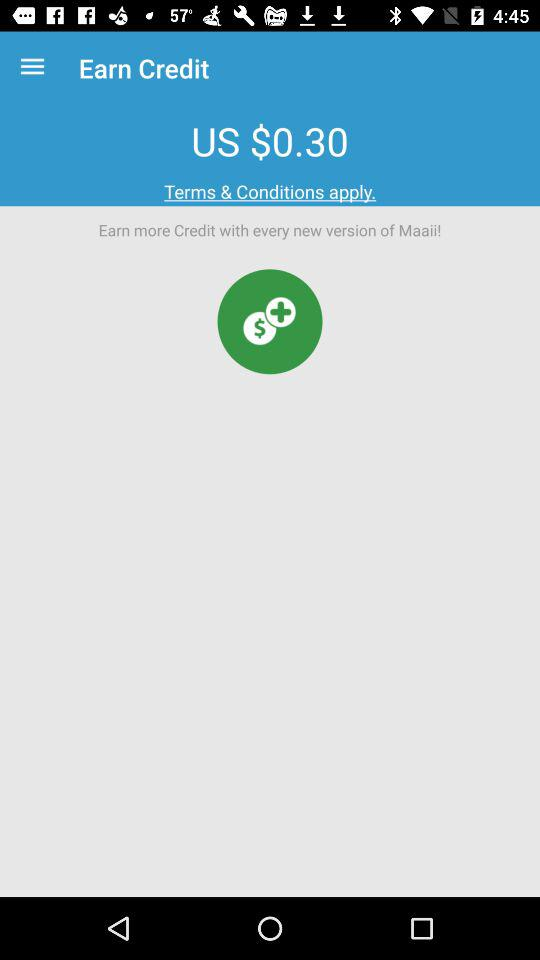How much credit is available for a new version of Maaii?
Answer the question using a single word or phrase. US $0.30 